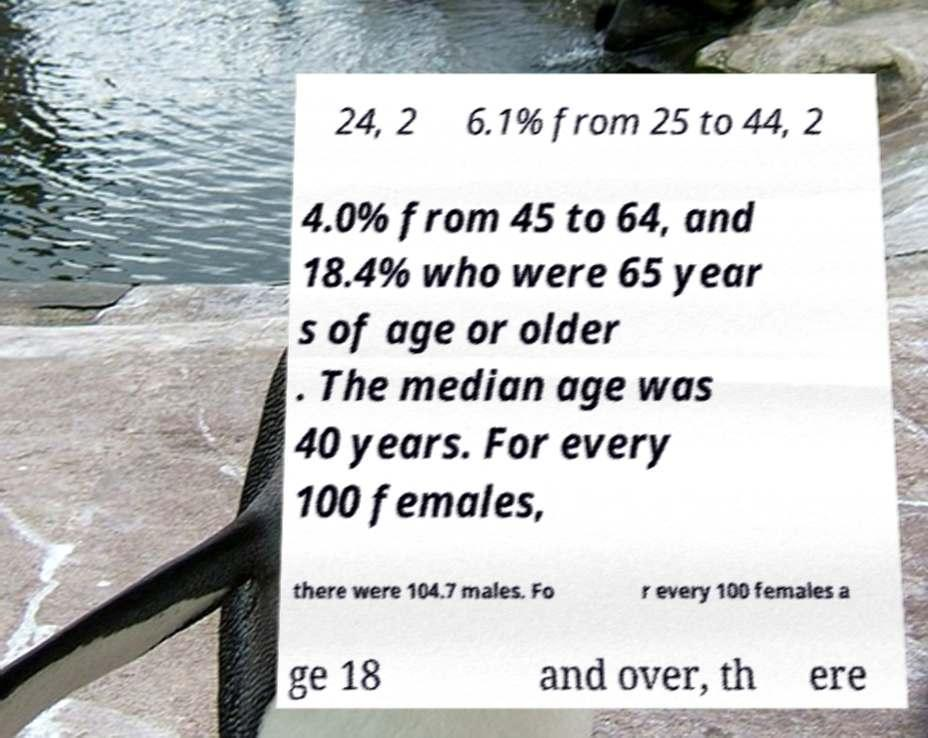Could you assist in decoding the text presented in this image and type it out clearly? 24, 2 6.1% from 25 to 44, 2 4.0% from 45 to 64, and 18.4% who were 65 year s of age or older . The median age was 40 years. For every 100 females, there were 104.7 males. Fo r every 100 females a ge 18 and over, th ere 